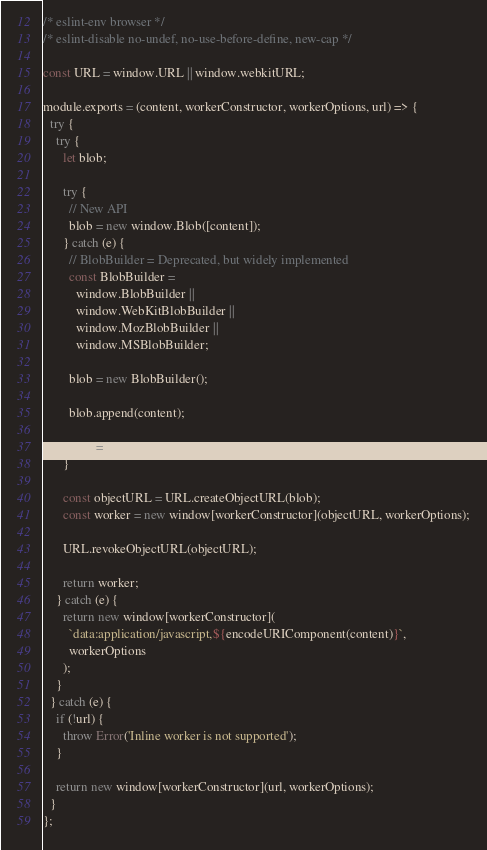Convert code to text. <code><loc_0><loc_0><loc_500><loc_500><_JavaScript_>/* eslint-env browser */
/* eslint-disable no-undef, no-use-before-define, new-cap */

const URL = window.URL || window.webkitURL;

module.exports = (content, workerConstructor, workerOptions, url) => {
  try {
    try {
      let blob;

      try {
        // New API
        blob = new window.Blob([content]);
      } catch (e) {
        // BlobBuilder = Deprecated, but widely implemented
        const BlobBuilder =
          window.BlobBuilder ||
          window.WebKitBlobBuilder ||
          window.MozBlobBuilder ||
          window.MSBlobBuilder;

        blob = new BlobBuilder();

        blob.append(content);

        blob = blob.getBlob();
      }

      const objectURL = URL.createObjectURL(blob);
      const worker = new window[workerConstructor](objectURL, workerOptions);

      URL.revokeObjectURL(objectURL);

      return worker;
    } catch (e) {
      return new window[workerConstructor](
        `data:application/javascript,${encodeURIComponent(content)}`,
        workerOptions
      );
    }
  } catch (e) {
    if (!url) {
      throw Error('Inline worker is not supported');
    }

    return new window[workerConstructor](url, workerOptions);
  }
};
</code> 